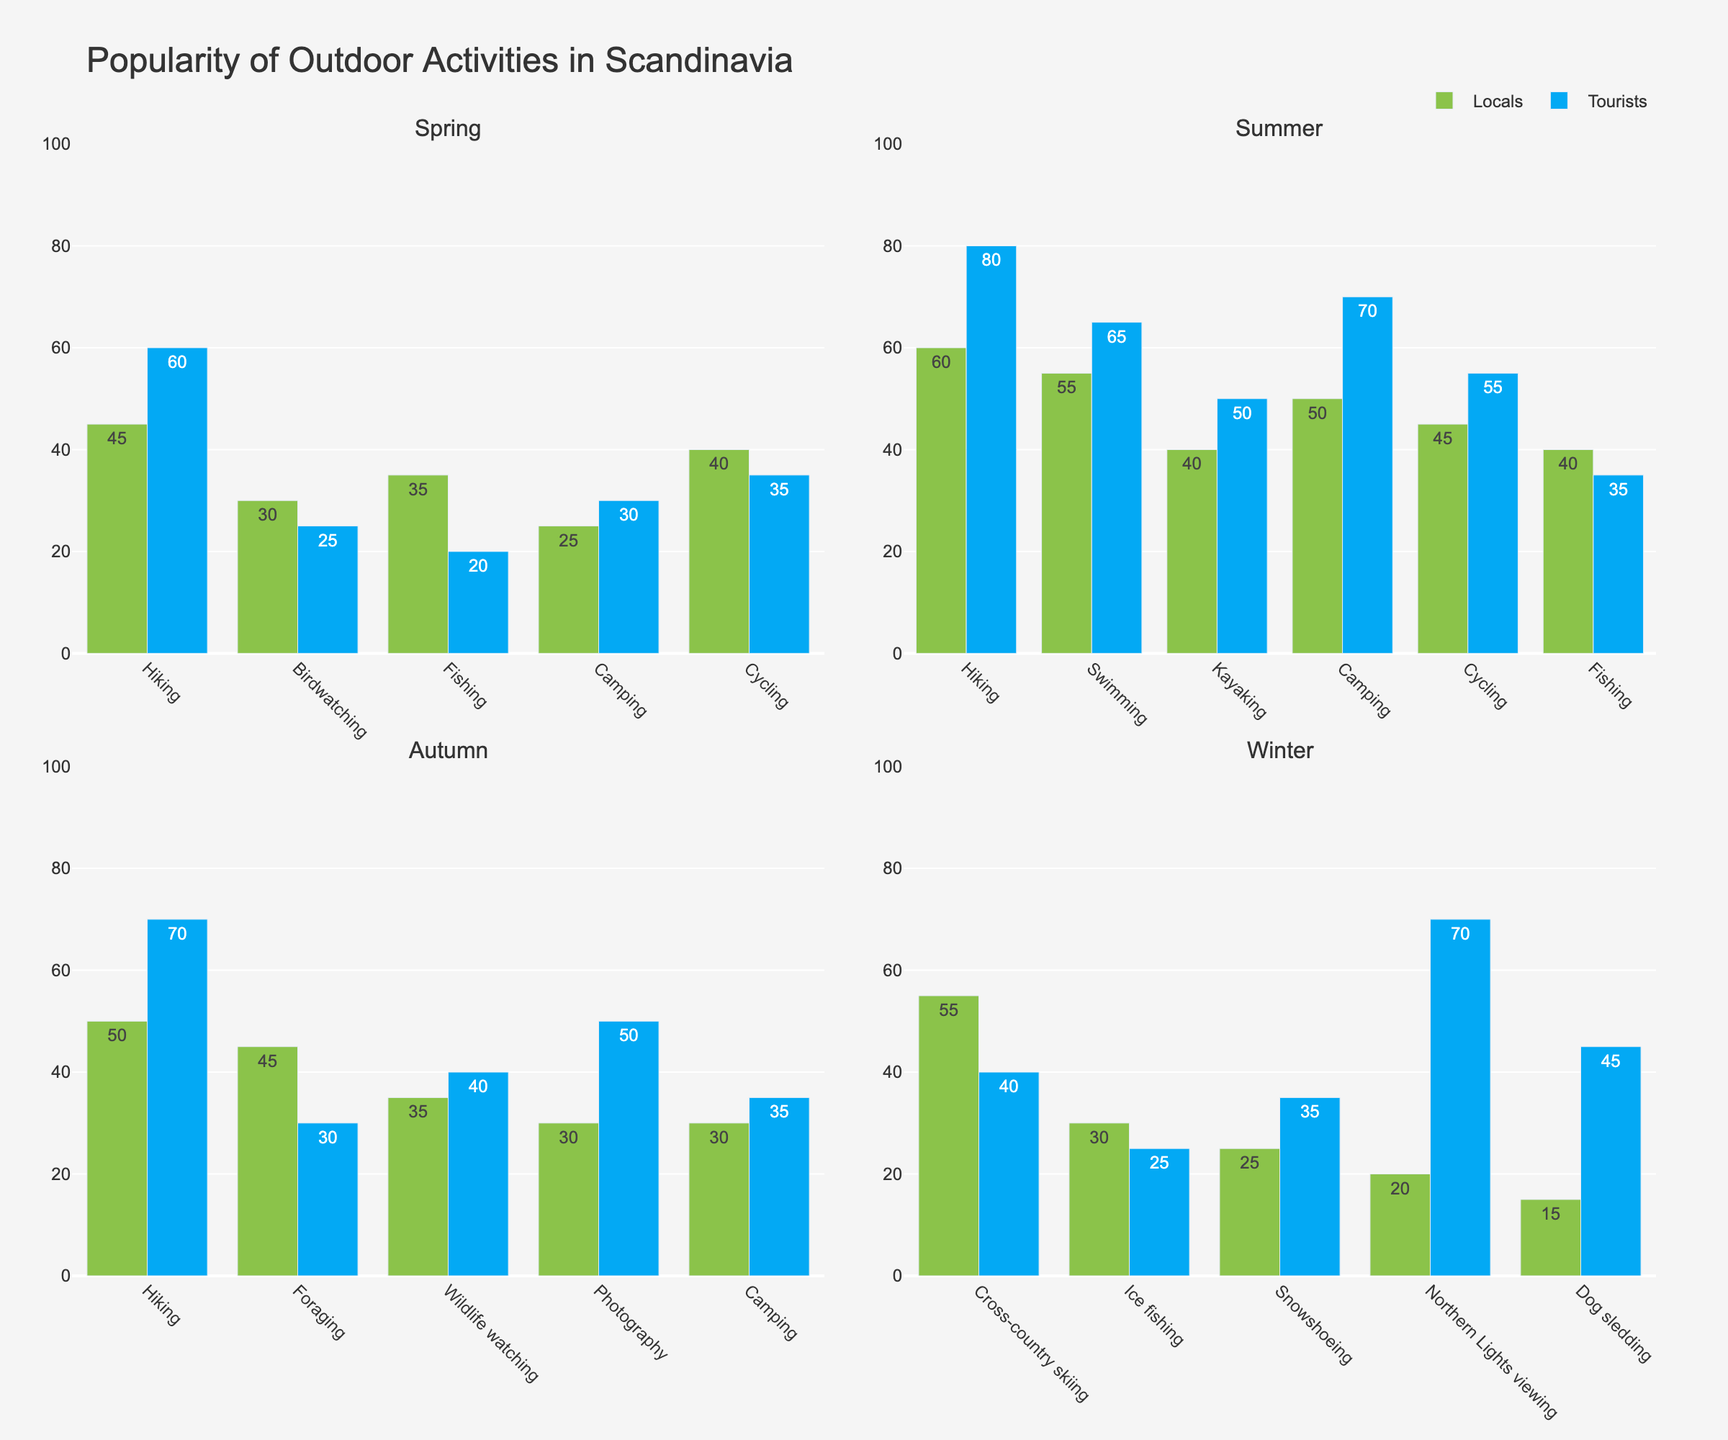What's the most popular activity among tourists in summer? By comparing the heights of the bars representing tourists' activities in summer, "Hiking" has the highest percentage at 80%.
Answer: Hiking Which activity shows the most significant difference in popularity between locals and tourists in winter? By examining the difference in bar heights for winter activities, "Northern Lights viewing" shows a significant difference with 20% for locals and 70% for tourists, a 50% difference.
Answer: Northern Lights viewing What is the average popularity of “Camping” across all seasons for locals? Add the popularity percentages for Camping among locals in all seasons and divide by the number of seasons: (25% (Spring) + 50% (Summer) + 30% (Autumn) + 0% (Winter)) / 4 = 105% / 4 = 26.25%.
Answer: 26.25% In spring, are there any activities more popular among tourists than locals? If so, which ones? Compare the bar heights for locals and tourists in spring. "Hiking" (60% tourists vs. 45% locals) and "Camping" (30% tourists vs. 25% locals) are more popular among tourists than locals.
Answer: Hiking, Camping Which season shows the highest popularity of "Hiking" among locals? By comparing the bar heights for "Hiking" across all seasons, the highest percentage for locals is in summer at 60%.
Answer: Summer How does the popularity of "Birdwatching" in spring compare to "Wildlife watching" in autumn among locals? "Birdwatching" in spring is at 30%, while "Wildlife watching" in autumn is at 35%. Therefore, "Wildlife watching" is more popular by 5%.
Answer: Wildlife watching is more popular by 5% What's the total popularity percentage of water-related activities (Swimming and Kayaking) among locals in summer? Add the percentages for “Swimming” and “Kayaking” for locals in summer: 55% (Swimming) + 40% (Kayaking) = 95%.
Answer: 95% Are there any activities exclusively popular in one season (i.e., not performed in other seasons) among tourists? By visually inspecting the bars for each activity across the seasons, "Northern Lights viewing" and "Dog sledding" in winter are not represented in other seasons for tourists.
Answer: Northern Lights viewing, Dog sledding Which activity has the least popularity among locals in winter? By comparing the heights of the bars for winter activities, "Dog sledding" is the least popular at 15%.
Answer: Dog sledding How much more popular is "Cycling" in summer among tourists compared to spring among tourists? Subtract the percentages of tourists doing "Cycling" in spring from summer: 55% (Summer) - 35% (Spring) = 20%.
Answer: 20% 